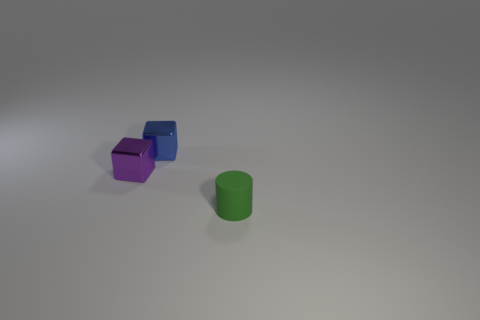Add 3 matte cylinders. How many objects exist? 6 Subtract all cubes. How many objects are left? 1 Add 2 purple objects. How many purple objects are left? 3 Add 3 small blue things. How many small blue things exist? 4 Subtract 0 gray blocks. How many objects are left? 3 Subtract all blue rubber cylinders. Subtract all cylinders. How many objects are left? 2 